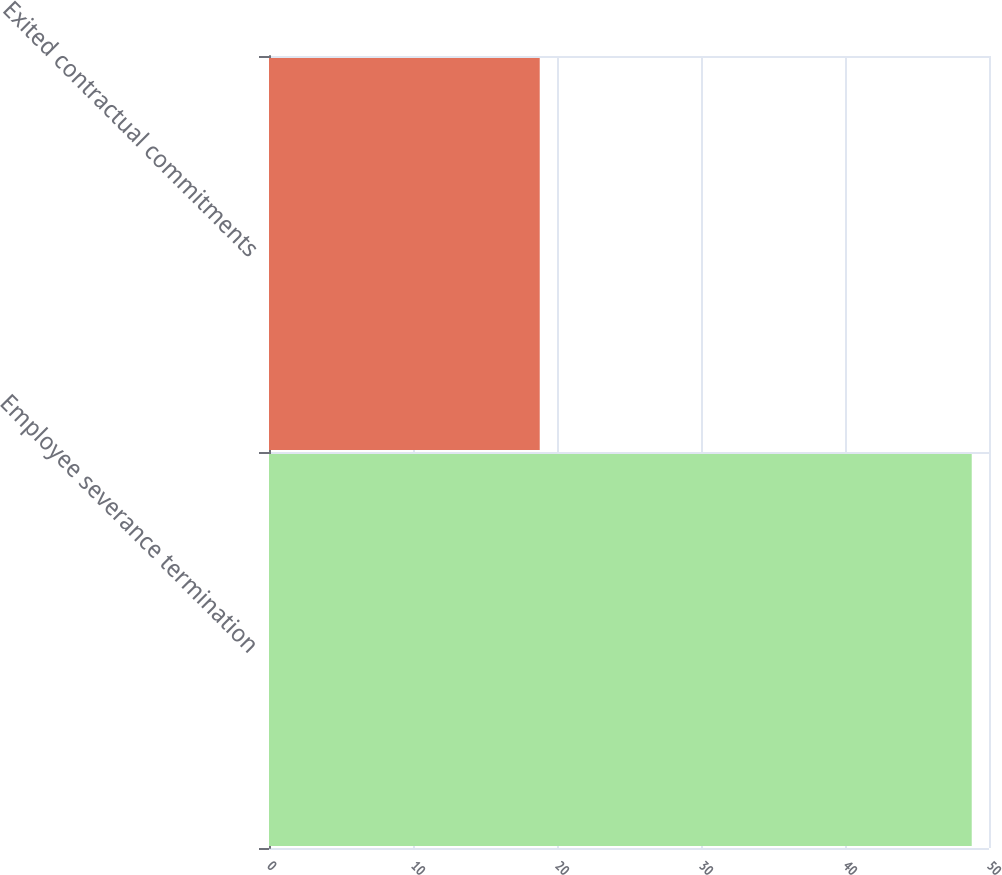<chart> <loc_0><loc_0><loc_500><loc_500><bar_chart><fcel>Employee severance termination<fcel>Exited contractual commitments<nl><fcel>48.8<fcel>18.8<nl></chart> 